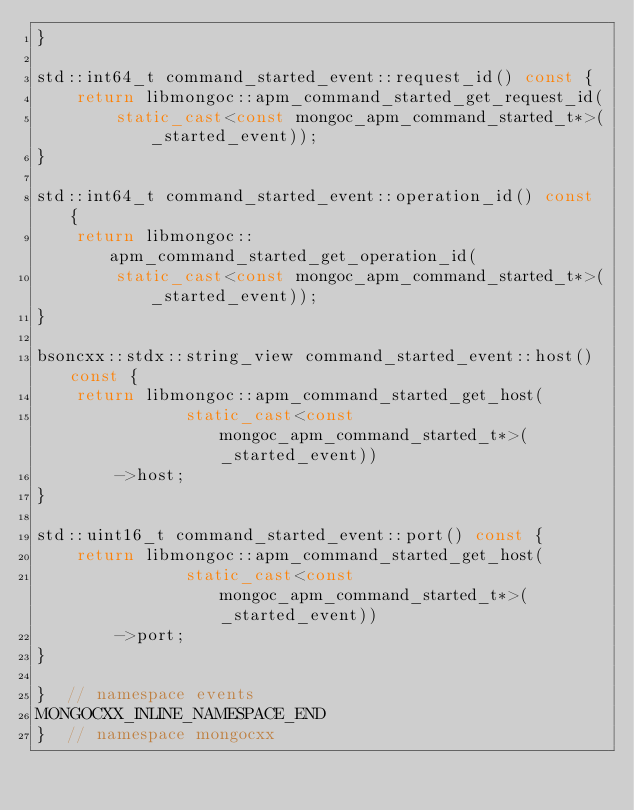Convert code to text. <code><loc_0><loc_0><loc_500><loc_500><_C++_>}

std::int64_t command_started_event::request_id() const {
    return libmongoc::apm_command_started_get_request_id(
        static_cast<const mongoc_apm_command_started_t*>(_started_event));
}

std::int64_t command_started_event::operation_id() const {
    return libmongoc::apm_command_started_get_operation_id(
        static_cast<const mongoc_apm_command_started_t*>(_started_event));
}

bsoncxx::stdx::string_view command_started_event::host() const {
    return libmongoc::apm_command_started_get_host(
               static_cast<const mongoc_apm_command_started_t*>(_started_event))
        ->host;
}

std::uint16_t command_started_event::port() const {
    return libmongoc::apm_command_started_get_host(
               static_cast<const mongoc_apm_command_started_t*>(_started_event))
        ->port;
}

}  // namespace events
MONGOCXX_INLINE_NAMESPACE_END
}  // namespace mongocxx
</code> 